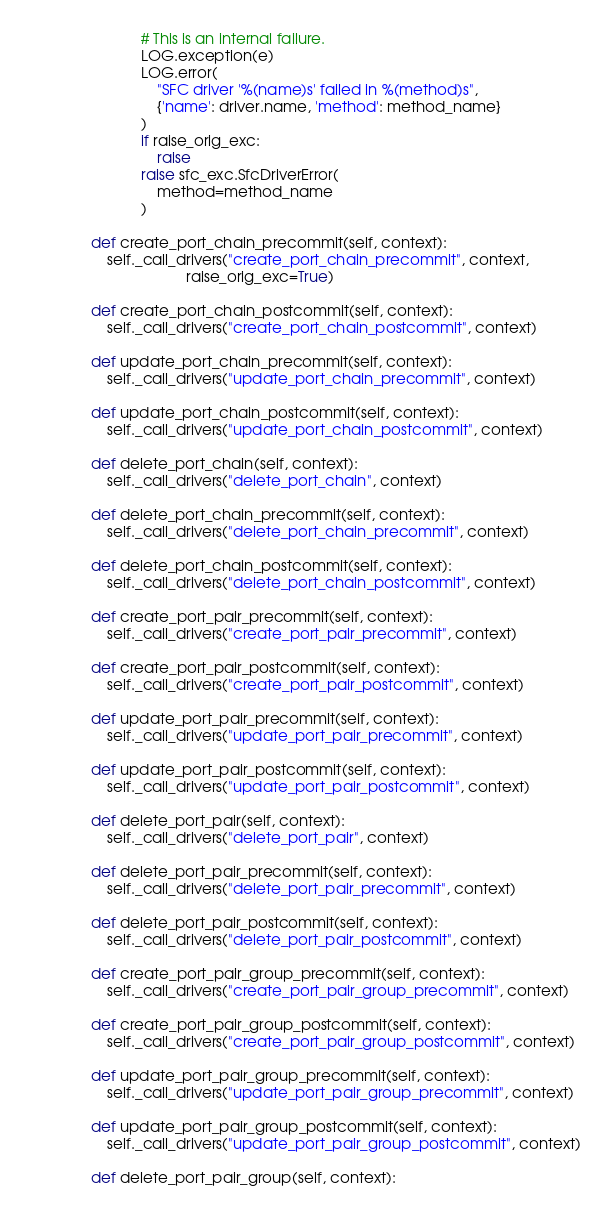Convert code to text. <code><loc_0><loc_0><loc_500><loc_500><_Python_>                # This is an internal failure.
                LOG.exception(e)
                LOG.error(
                    "SFC driver '%(name)s' failed in %(method)s",
                    {'name': driver.name, 'method': method_name}
                )
                if raise_orig_exc:
                    raise
                raise sfc_exc.SfcDriverError(
                    method=method_name
                )

    def create_port_chain_precommit(self, context):
        self._call_drivers("create_port_chain_precommit", context,
                           raise_orig_exc=True)

    def create_port_chain_postcommit(self, context):
        self._call_drivers("create_port_chain_postcommit", context)

    def update_port_chain_precommit(self, context):
        self._call_drivers("update_port_chain_precommit", context)

    def update_port_chain_postcommit(self, context):
        self._call_drivers("update_port_chain_postcommit", context)

    def delete_port_chain(self, context):
        self._call_drivers("delete_port_chain", context)

    def delete_port_chain_precommit(self, context):
        self._call_drivers("delete_port_chain_precommit", context)

    def delete_port_chain_postcommit(self, context):
        self._call_drivers("delete_port_chain_postcommit", context)

    def create_port_pair_precommit(self, context):
        self._call_drivers("create_port_pair_precommit", context)

    def create_port_pair_postcommit(self, context):
        self._call_drivers("create_port_pair_postcommit", context)

    def update_port_pair_precommit(self, context):
        self._call_drivers("update_port_pair_precommit", context)

    def update_port_pair_postcommit(self, context):
        self._call_drivers("update_port_pair_postcommit", context)

    def delete_port_pair(self, context):
        self._call_drivers("delete_port_pair", context)

    def delete_port_pair_precommit(self, context):
        self._call_drivers("delete_port_pair_precommit", context)

    def delete_port_pair_postcommit(self, context):
        self._call_drivers("delete_port_pair_postcommit", context)

    def create_port_pair_group_precommit(self, context):
        self._call_drivers("create_port_pair_group_precommit", context)

    def create_port_pair_group_postcommit(self, context):
        self._call_drivers("create_port_pair_group_postcommit", context)

    def update_port_pair_group_precommit(self, context):
        self._call_drivers("update_port_pair_group_precommit", context)

    def update_port_pair_group_postcommit(self, context):
        self._call_drivers("update_port_pair_group_postcommit", context)

    def delete_port_pair_group(self, context):</code> 